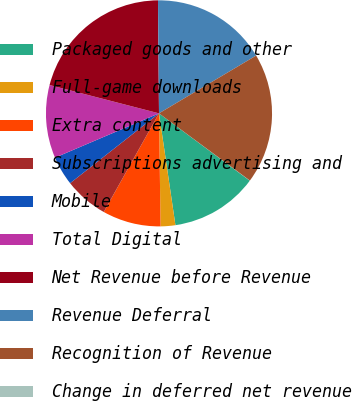Convert chart. <chart><loc_0><loc_0><loc_500><loc_500><pie_chart><fcel>Packaged goods and other<fcel>Full-game downloads<fcel>Extra content<fcel>Subscriptions advertising and<fcel>Mobile<fcel>Total Digital<fcel>Net Revenue before Revenue<fcel>Revenue Deferral<fcel>Recognition of Revenue<fcel>Change in deferred net revenue<nl><fcel>12.52%<fcel>2.1%<fcel>8.35%<fcel>6.27%<fcel>4.19%<fcel>10.44%<fcel>20.83%<fcel>16.6%<fcel>18.68%<fcel>0.02%<nl></chart> 